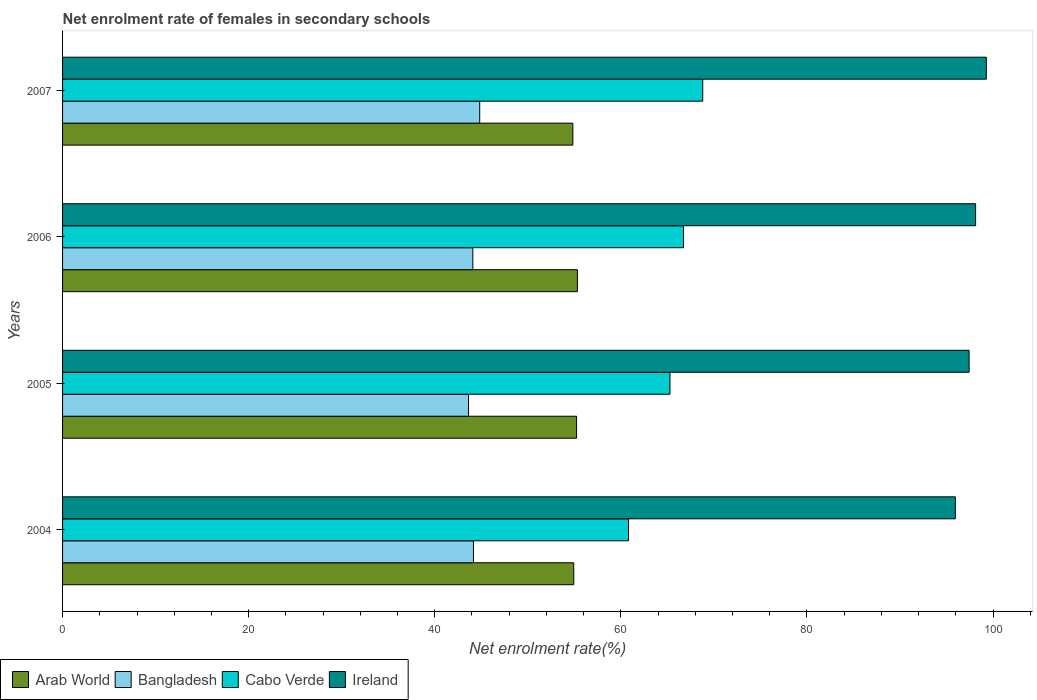How many different coloured bars are there?
Ensure brevity in your answer.  4. How many groups of bars are there?
Provide a succinct answer. 4. Are the number of bars per tick equal to the number of legend labels?
Provide a succinct answer. Yes. How many bars are there on the 4th tick from the top?
Offer a very short reply. 4. In how many cases, is the number of bars for a given year not equal to the number of legend labels?
Your answer should be very brief. 0. What is the net enrolment rate of females in secondary schools in Ireland in 2005?
Offer a very short reply. 97.43. Across all years, what is the maximum net enrolment rate of females in secondary schools in Arab World?
Ensure brevity in your answer.  55.33. Across all years, what is the minimum net enrolment rate of females in secondary schools in Cabo Verde?
Keep it short and to the point. 60.83. In which year was the net enrolment rate of females in secondary schools in Arab World minimum?
Offer a very short reply. 2007. What is the total net enrolment rate of females in secondary schools in Bangladesh in the graph?
Your answer should be compact. 176.72. What is the difference between the net enrolment rate of females in secondary schools in Arab World in 2004 and that in 2006?
Keep it short and to the point. -0.39. What is the difference between the net enrolment rate of females in secondary schools in Bangladesh in 2004 and the net enrolment rate of females in secondary schools in Arab World in 2006?
Your response must be concise. -11.17. What is the average net enrolment rate of females in secondary schools in Cabo Verde per year?
Give a very brief answer. 65.41. In the year 2007, what is the difference between the net enrolment rate of females in secondary schools in Bangladesh and net enrolment rate of females in secondary schools in Ireland?
Your answer should be compact. -54.45. In how many years, is the net enrolment rate of females in secondary schools in Bangladesh greater than 28 %?
Offer a very short reply. 4. What is the ratio of the net enrolment rate of females in secondary schools in Bangladesh in 2004 to that in 2007?
Your response must be concise. 0.99. Is the net enrolment rate of females in secondary schools in Bangladesh in 2005 less than that in 2006?
Your answer should be very brief. Yes. Is the difference between the net enrolment rate of females in secondary schools in Bangladesh in 2004 and 2006 greater than the difference between the net enrolment rate of females in secondary schools in Ireland in 2004 and 2006?
Your response must be concise. Yes. What is the difference between the highest and the second highest net enrolment rate of females in secondary schools in Cabo Verde?
Your answer should be compact. 2.07. What is the difference between the highest and the lowest net enrolment rate of females in secondary schools in Arab World?
Keep it short and to the point. 0.49. In how many years, is the net enrolment rate of females in secondary schools in Cabo Verde greater than the average net enrolment rate of females in secondary schools in Cabo Verde taken over all years?
Provide a succinct answer. 2. What does the 3rd bar from the top in 2005 represents?
Ensure brevity in your answer.  Bangladesh. What does the 3rd bar from the bottom in 2004 represents?
Make the answer very short. Cabo Verde. How many bars are there?
Make the answer very short. 16. Are all the bars in the graph horizontal?
Ensure brevity in your answer.  Yes. Are the values on the major ticks of X-axis written in scientific E-notation?
Your response must be concise. No. Does the graph contain any zero values?
Your answer should be compact. No. Does the graph contain grids?
Offer a very short reply. No. Where does the legend appear in the graph?
Provide a short and direct response. Bottom left. What is the title of the graph?
Your response must be concise. Net enrolment rate of females in secondary schools. What is the label or title of the X-axis?
Keep it short and to the point. Net enrolment rate(%). What is the label or title of the Y-axis?
Provide a succinct answer. Years. What is the Net enrolment rate(%) of Arab World in 2004?
Provide a succinct answer. 54.94. What is the Net enrolment rate(%) in Bangladesh in 2004?
Provide a short and direct response. 44.16. What is the Net enrolment rate(%) of Cabo Verde in 2004?
Provide a short and direct response. 60.83. What is the Net enrolment rate(%) of Ireland in 2004?
Your answer should be very brief. 95.95. What is the Net enrolment rate(%) of Arab World in 2005?
Keep it short and to the point. 55.25. What is the Net enrolment rate(%) in Bangladesh in 2005?
Your answer should be compact. 43.63. What is the Net enrolment rate(%) in Cabo Verde in 2005?
Offer a very short reply. 65.28. What is the Net enrolment rate(%) in Ireland in 2005?
Offer a terse response. 97.43. What is the Net enrolment rate(%) in Arab World in 2006?
Give a very brief answer. 55.33. What is the Net enrolment rate(%) in Bangladesh in 2006?
Your response must be concise. 44.1. What is the Net enrolment rate(%) in Cabo Verde in 2006?
Provide a short and direct response. 66.73. What is the Net enrolment rate(%) of Ireland in 2006?
Provide a short and direct response. 98.13. What is the Net enrolment rate(%) in Arab World in 2007?
Your answer should be compact. 54.84. What is the Net enrolment rate(%) of Bangladesh in 2007?
Ensure brevity in your answer.  44.83. What is the Net enrolment rate(%) of Cabo Verde in 2007?
Your answer should be compact. 68.8. What is the Net enrolment rate(%) in Ireland in 2007?
Make the answer very short. 99.28. Across all years, what is the maximum Net enrolment rate(%) of Arab World?
Offer a very short reply. 55.33. Across all years, what is the maximum Net enrolment rate(%) of Bangladesh?
Your answer should be very brief. 44.83. Across all years, what is the maximum Net enrolment rate(%) of Cabo Verde?
Your answer should be compact. 68.8. Across all years, what is the maximum Net enrolment rate(%) in Ireland?
Offer a terse response. 99.28. Across all years, what is the minimum Net enrolment rate(%) of Arab World?
Keep it short and to the point. 54.84. Across all years, what is the minimum Net enrolment rate(%) in Bangladesh?
Your answer should be compact. 43.63. Across all years, what is the minimum Net enrolment rate(%) in Cabo Verde?
Your answer should be very brief. 60.83. Across all years, what is the minimum Net enrolment rate(%) in Ireland?
Give a very brief answer. 95.95. What is the total Net enrolment rate(%) in Arab World in the graph?
Keep it short and to the point. 220.36. What is the total Net enrolment rate(%) of Bangladesh in the graph?
Ensure brevity in your answer.  176.72. What is the total Net enrolment rate(%) of Cabo Verde in the graph?
Your answer should be very brief. 261.65. What is the total Net enrolment rate(%) in Ireland in the graph?
Offer a very short reply. 390.79. What is the difference between the Net enrolment rate(%) of Arab World in 2004 and that in 2005?
Your answer should be very brief. -0.31. What is the difference between the Net enrolment rate(%) of Bangladesh in 2004 and that in 2005?
Make the answer very short. 0.53. What is the difference between the Net enrolment rate(%) of Cabo Verde in 2004 and that in 2005?
Provide a succinct answer. -4.46. What is the difference between the Net enrolment rate(%) in Ireland in 2004 and that in 2005?
Provide a short and direct response. -1.48. What is the difference between the Net enrolment rate(%) of Arab World in 2004 and that in 2006?
Ensure brevity in your answer.  -0.39. What is the difference between the Net enrolment rate(%) in Bangladesh in 2004 and that in 2006?
Your response must be concise. 0.07. What is the difference between the Net enrolment rate(%) of Cabo Verde in 2004 and that in 2006?
Your answer should be compact. -5.91. What is the difference between the Net enrolment rate(%) of Ireland in 2004 and that in 2006?
Give a very brief answer. -2.18. What is the difference between the Net enrolment rate(%) in Arab World in 2004 and that in 2007?
Your answer should be compact. 0.1. What is the difference between the Net enrolment rate(%) in Bangladesh in 2004 and that in 2007?
Make the answer very short. -0.67. What is the difference between the Net enrolment rate(%) in Cabo Verde in 2004 and that in 2007?
Ensure brevity in your answer.  -7.98. What is the difference between the Net enrolment rate(%) in Ireland in 2004 and that in 2007?
Provide a succinct answer. -3.33. What is the difference between the Net enrolment rate(%) in Arab World in 2005 and that in 2006?
Offer a terse response. -0.09. What is the difference between the Net enrolment rate(%) in Bangladesh in 2005 and that in 2006?
Keep it short and to the point. -0.46. What is the difference between the Net enrolment rate(%) in Cabo Verde in 2005 and that in 2006?
Provide a succinct answer. -1.45. What is the difference between the Net enrolment rate(%) of Ireland in 2005 and that in 2006?
Your answer should be very brief. -0.7. What is the difference between the Net enrolment rate(%) in Arab World in 2005 and that in 2007?
Provide a succinct answer. 0.4. What is the difference between the Net enrolment rate(%) of Bangladesh in 2005 and that in 2007?
Make the answer very short. -1.2. What is the difference between the Net enrolment rate(%) in Cabo Verde in 2005 and that in 2007?
Make the answer very short. -3.52. What is the difference between the Net enrolment rate(%) in Ireland in 2005 and that in 2007?
Your response must be concise. -1.85. What is the difference between the Net enrolment rate(%) of Arab World in 2006 and that in 2007?
Provide a succinct answer. 0.49. What is the difference between the Net enrolment rate(%) in Bangladesh in 2006 and that in 2007?
Provide a short and direct response. -0.74. What is the difference between the Net enrolment rate(%) of Cabo Verde in 2006 and that in 2007?
Offer a very short reply. -2.07. What is the difference between the Net enrolment rate(%) of Ireland in 2006 and that in 2007?
Give a very brief answer. -1.15. What is the difference between the Net enrolment rate(%) in Arab World in 2004 and the Net enrolment rate(%) in Bangladesh in 2005?
Your response must be concise. 11.31. What is the difference between the Net enrolment rate(%) in Arab World in 2004 and the Net enrolment rate(%) in Cabo Verde in 2005?
Offer a very short reply. -10.34. What is the difference between the Net enrolment rate(%) of Arab World in 2004 and the Net enrolment rate(%) of Ireland in 2005?
Make the answer very short. -42.49. What is the difference between the Net enrolment rate(%) in Bangladesh in 2004 and the Net enrolment rate(%) in Cabo Verde in 2005?
Provide a succinct answer. -21.12. What is the difference between the Net enrolment rate(%) of Bangladesh in 2004 and the Net enrolment rate(%) of Ireland in 2005?
Provide a short and direct response. -53.27. What is the difference between the Net enrolment rate(%) in Cabo Verde in 2004 and the Net enrolment rate(%) in Ireland in 2005?
Make the answer very short. -36.6. What is the difference between the Net enrolment rate(%) of Arab World in 2004 and the Net enrolment rate(%) of Bangladesh in 2006?
Your answer should be very brief. 10.84. What is the difference between the Net enrolment rate(%) in Arab World in 2004 and the Net enrolment rate(%) in Cabo Verde in 2006?
Provide a short and direct response. -11.8. What is the difference between the Net enrolment rate(%) in Arab World in 2004 and the Net enrolment rate(%) in Ireland in 2006?
Give a very brief answer. -43.19. What is the difference between the Net enrolment rate(%) in Bangladesh in 2004 and the Net enrolment rate(%) in Cabo Verde in 2006?
Keep it short and to the point. -22.57. What is the difference between the Net enrolment rate(%) of Bangladesh in 2004 and the Net enrolment rate(%) of Ireland in 2006?
Your answer should be very brief. -53.97. What is the difference between the Net enrolment rate(%) in Cabo Verde in 2004 and the Net enrolment rate(%) in Ireland in 2006?
Offer a very short reply. -37.3. What is the difference between the Net enrolment rate(%) of Arab World in 2004 and the Net enrolment rate(%) of Bangladesh in 2007?
Provide a short and direct response. 10.11. What is the difference between the Net enrolment rate(%) of Arab World in 2004 and the Net enrolment rate(%) of Cabo Verde in 2007?
Provide a succinct answer. -13.86. What is the difference between the Net enrolment rate(%) of Arab World in 2004 and the Net enrolment rate(%) of Ireland in 2007?
Offer a very short reply. -44.34. What is the difference between the Net enrolment rate(%) of Bangladesh in 2004 and the Net enrolment rate(%) of Cabo Verde in 2007?
Provide a short and direct response. -24.64. What is the difference between the Net enrolment rate(%) in Bangladesh in 2004 and the Net enrolment rate(%) in Ireland in 2007?
Your answer should be very brief. -55.12. What is the difference between the Net enrolment rate(%) of Cabo Verde in 2004 and the Net enrolment rate(%) of Ireland in 2007?
Your response must be concise. -38.45. What is the difference between the Net enrolment rate(%) in Arab World in 2005 and the Net enrolment rate(%) in Bangladesh in 2006?
Provide a short and direct response. 11.15. What is the difference between the Net enrolment rate(%) in Arab World in 2005 and the Net enrolment rate(%) in Cabo Verde in 2006?
Make the answer very short. -11.49. What is the difference between the Net enrolment rate(%) of Arab World in 2005 and the Net enrolment rate(%) of Ireland in 2006?
Provide a succinct answer. -42.88. What is the difference between the Net enrolment rate(%) in Bangladesh in 2005 and the Net enrolment rate(%) in Cabo Verde in 2006?
Ensure brevity in your answer.  -23.1. What is the difference between the Net enrolment rate(%) in Bangladesh in 2005 and the Net enrolment rate(%) in Ireland in 2006?
Make the answer very short. -54.5. What is the difference between the Net enrolment rate(%) in Cabo Verde in 2005 and the Net enrolment rate(%) in Ireland in 2006?
Provide a succinct answer. -32.85. What is the difference between the Net enrolment rate(%) of Arab World in 2005 and the Net enrolment rate(%) of Bangladesh in 2007?
Provide a short and direct response. 10.41. What is the difference between the Net enrolment rate(%) of Arab World in 2005 and the Net enrolment rate(%) of Cabo Verde in 2007?
Provide a succinct answer. -13.56. What is the difference between the Net enrolment rate(%) of Arab World in 2005 and the Net enrolment rate(%) of Ireland in 2007?
Keep it short and to the point. -44.03. What is the difference between the Net enrolment rate(%) in Bangladesh in 2005 and the Net enrolment rate(%) in Cabo Verde in 2007?
Keep it short and to the point. -25.17. What is the difference between the Net enrolment rate(%) in Bangladesh in 2005 and the Net enrolment rate(%) in Ireland in 2007?
Give a very brief answer. -55.65. What is the difference between the Net enrolment rate(%) of Cabo Verde in 2005 and the Net enrolment rate(%) of Ireland in 2007?
Give a very brief answer. -34. What is the difference between the Net enrolment rate(%) of Arab World in 2006 and the Net enrolment rate(%) of Bangladesh in 2007?
Your answer should be very brief. 10.5. What is the difference between the Net enrolment rate(%) of Arab World in 2006 and the Net enrolment rate(%) of Cabo Verde in 2007?
Your answer should be very brief. -13.47. What is the difference between the Net enrolment rate(%) in Arab World in 2006 and the Net enrolment rate(%) in Ireland in 2007?
Your answer should be very brief. -43.95. What is the difference between the Net enrolment rate(%) in Bangladesh in 2006 and the Net enrolment rate(%) in Cabo Verde in 2007?
Provide a succinct answer. -24.71. What is the difference between the Net enrolment rate(%) of Bangladesh in 2006 and the Net enrolment rate(%) of Ireland in 2007?
Provide a short and direct response. -55.18. What is the difference between the Net enrolment rate(%) in Cabo Verde in 2006 and the Net enrolment rate(%) in Ireland in 2007?
Offer a terse response. -32.55. What is the average Net enrolment rate(%) of Arab World per year?
Give a very brief answer. 55.09. What is the average Net enrolment rate(%) in Bangladesh per year?
Your response must be concise. 44.18. What is the average Net enrolment rate(%) of Cabo Verde per year?
Your response must be concise. 65.41. What is the average Net enrolment rate(%) in Ireland per year?
Your answer should be compact. 97.7. In the year 2004, what is the difference between the Net enrolment rate(%) of Arab World and Net enrolment rate(%) of Bangladesh?
Give a very brief answer. 10.78. In the year 2004, what is the difference between the Net enrolment rate(%) in Arab World and Net enrolment rate(%) in Cabo Verde?
Offer a very short reply. -5.89. In the year 2004, what is the difference between the Net enrolment rate(%) of Arab World and Net enrolment rate(%) of Ireland?
Ensure brevity in your answer.  -41.01. In the year 2004, what is the difference between the Net enrolment rate(%) in Bangladesh and Net enrolment rate(%) in Cabo Verde?
Offer a terse response. -16.67. In the year 2004, what is the difference between the Net enrolment rate(%) in Bangladesh and Net enrolment rate(%) in Ireland?
Offer a terse response. -51.79. In the year 2004, what is the difference between the Net enrolment rate(%) in Cabo Verde and Net enrolment rate(%) in Ireland?
Offer a terse response. -35.13. In the year 2005, what is the difference between the Net enrolment rate(%) in Arab World and Net enrolment rate(%) in Bangladesh?
Keep it short and to the point. 11.62. In the year 2005, what is the difference between the Net enrolment rate(%) of Arab World and Net enrolment rate(%) of Cabo Verde?
Provide a succinct answer. -10.03. In the year 2005, what is the difference between the Net enrolment rate(%) of Arab World and Net enrolment rate(%) of Ireland?
Your answer should be very brief. -42.18. In the year 2005, what is the difference between the Net enrolment rate(%) of Bangladesh and Net enrolment rate(%) of Cabo Verde?
Offer a terse response. -21.65. In the year 2005, what is the difference between the Net enrolment rate(%) in Bangladesh and Net enrolment rate(%) in Ireland?
Offer a terse response. -53.8. In the year 2005, what is the difference between the Net enrolment rate(%) of Cabo Verde and Net enrolment rate(%) of Ireland?
Provide a succinct answer. -32.15. In the year 2006, what is the difference between the Net enrolment rate(%) in Arab World and Net enrolment rate(%) in Bangladesh?
Ensure brevity in your answer.  11.24. In the year 2006, what is the difference between the Net enrolment rate(%) in Arab World and Net enrolment rate(%) in Cabo Verde?
Your answer should be compact. -11.4. In the year 2006, what is the difference between the Net enrolment rate(%) in Arab World and Net enrolment rate(%) in Ireland?
Your response must be concise. -42.8. In the year 2006, what is the difference between the Net enrolment rate(%) in Bangladesh and Net enrolment rate(%) in Cabo Verde?
Your response must be concise. -22.64. In the year 2006, what is the difference between the Net enrolment rate(%) of Bangladesh and Net enrolment rate(%) of Ireland?
Offer a terse response. -54.03. In the year 2006, what is the difference between the Net enrolment rate(%) of Cabo Verde and Net enrolment rate(%) of Ireland?
Make the answer very short. -31.39. In the year 2007, what is the difference between the Net enrolment rate(%) of Arab World and Net enrolment rate(%) of Bangladesh?
Your answer should be very brief. 10.01. In the year 2007, what is the difference between the Net enrolment rate(%) in Arab World and Net enrolment rate(%) in Cabo Verde?
Your answer should be very brief. -13.96. In the year 2007, what is the difference between the Net enrolment rate(%) in Arab World and Net enrolment rate(%) in Ireland?
Your response must be concise. -44.44. In the year 2007, what is the difference between the Net enrolment rate(%) in Bangladesh and Net enrolment rate(%) in Cabo Verde?
Your answer should be compact. -23.97. In the year 2007, what is the difference between the Net enrolment rate(%) in Bangladesh and Net enrolment rate(%) in Ireland?
Provide a short and direct response. -54.45. In the year 2007, what is the difference between the Net enrolment rate(%) of Cabo Verde and Net enrolment rate(%) of Ireland?
Provide a succinct answer. -30.48. What is the ratio of the Net enrolment rate(%) of Arab World in 2004 to that in 2005?
Keep it short and to the point. 0.99. What is the ratio of the Net enrolment rate(%) of Bangladesh in 2004 to that in 2005?
Offer a very short reply. 1.01. What is the ratio of the Net enrolment rate(%) of Cabo Verde in 2004 to that in 2005?
Your answer should be compact. 0.93. What is the ratio of the Net enrolment rate(%) of Ireland in 2004 to that in 2005?
Provide a succinct answer. 0.98. What is the ratio of the Net enrolment rate(%) in Bangladesh in 2004 to that in 2006?
Provide a succinct answer. 1. What is the ratio of the Net enrolment rate(%) in Cabo Verde in 2004 to that in 2006?
Ensure brevity in your answer.  0.91. What is the ratio of the Net enrolment rate(%) in Ireland in 2004 to that in 2006?
Offer a terse response. 0.98. What is the ratio of the Net enrolment rate(%) of Cabo Verde in 2004 to that in 2007?
Your answer should be compact. 0.88. What is the ratio of the Net enrolment rate(%) in Ireland in 2004 to that in 2007?
Make the answer very short. 0.97. What is the ratio of the Net enrolment rate(%) of Arab World in 2005 to that in 2006?
Provide a short and direct response. 1. What is the ratio of the Net enrolment rate(%) of Cabo Verde in 2005 to that in 2006?
Offer a very short reply. 0.98. What is the ratio of the Net enrolment rate(%) of Ireland in 2005 to that in 2006?
Your answer should be very brief. 0.99. What is the ratio of the Net enrolment rate(%) in Arab World in 2005 to that in 2007?
Ensure brevity in your answer.  1.01. What is the ratio of the Net enrolment rate(%) in Bangladesh in 2005 to that in 2007?
Offer a terse response. 0.97. What is the ratio of the Net enrolment rate(%) in Cabo Verde in 2005 to that in 2007?
Provide a short and direct response. 0.95. What is the ratio of the Net enrolment rate(%) of Ireland in 2005 to that in 2007?
Provide a short and direct response. 0.98. What is the ratio of the Net enrolment rate(%) of Arab World in 2006 to that in 2007?
Offer a terse response. 1.01. What is the ratio of the Net enrolment rate(%) in Bangladesh in 2006 to that in 2007?
Offer a terse response. 0.98. What is the ratio of the Net enrolment rate(%) in Cabo Verde in 2006 to that in 2007?
Keep it short and to the point. 0.97. What is the ratio of the Net enrolment rate(%) in Ireland in 2006 to that in 2007?
Your answer should be compact. 0.99. What is the difference between the highest and the second highest Net enrolment rate(%) of Arab World?
Provide a short and direct response. 0.09. What is the difference between the highest and the second highest Net enrolment rate(%) of Bangladesh?
Keep it short and to the point. 0.67. What is the difference between the highest and the second highest Net enrolment rate(%) in Cabo Verde?
Give a very brief answer. 2.07. What is the difference between the highest and the second highest Net enrolment rate(%) of Ireland?
Keep it short and to the point. 1.15. What is the difference between the highest and the lowest Net enrolment rate(%) of Arab World?
Ensure brevity in your answer.  0.49. What is the difference between the highest and the lowest Net enrolment rate(%) in Bangladesh?
Ensure brevity in your answer.  1.2. What is the difference between the highest and the lowest Net enrolment rate(%) of Cabo Verde?
Offer a terse response. 7.98. What is the difference between the highest and the lowest Net enrolment rate(%) of Ireland?
Your response must be concise. 3.33. 